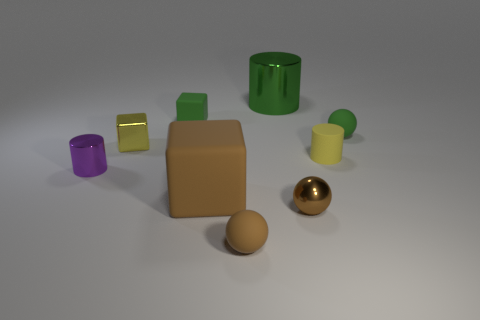Add 1 spheres. How many objects exist? 10 Subtract all cylinders. How many objects are left? 6 Subtract 1 green cylinders. How many objects are left? 8 Subtract all big green metal things. Subtract all small green rubber cubes. How many objects are left? 7 Add 7 brown matte cubes. How many brown matte cubes are left? 8 Add 8 small yellow blocks. How many small yellow blocks exist? 9 